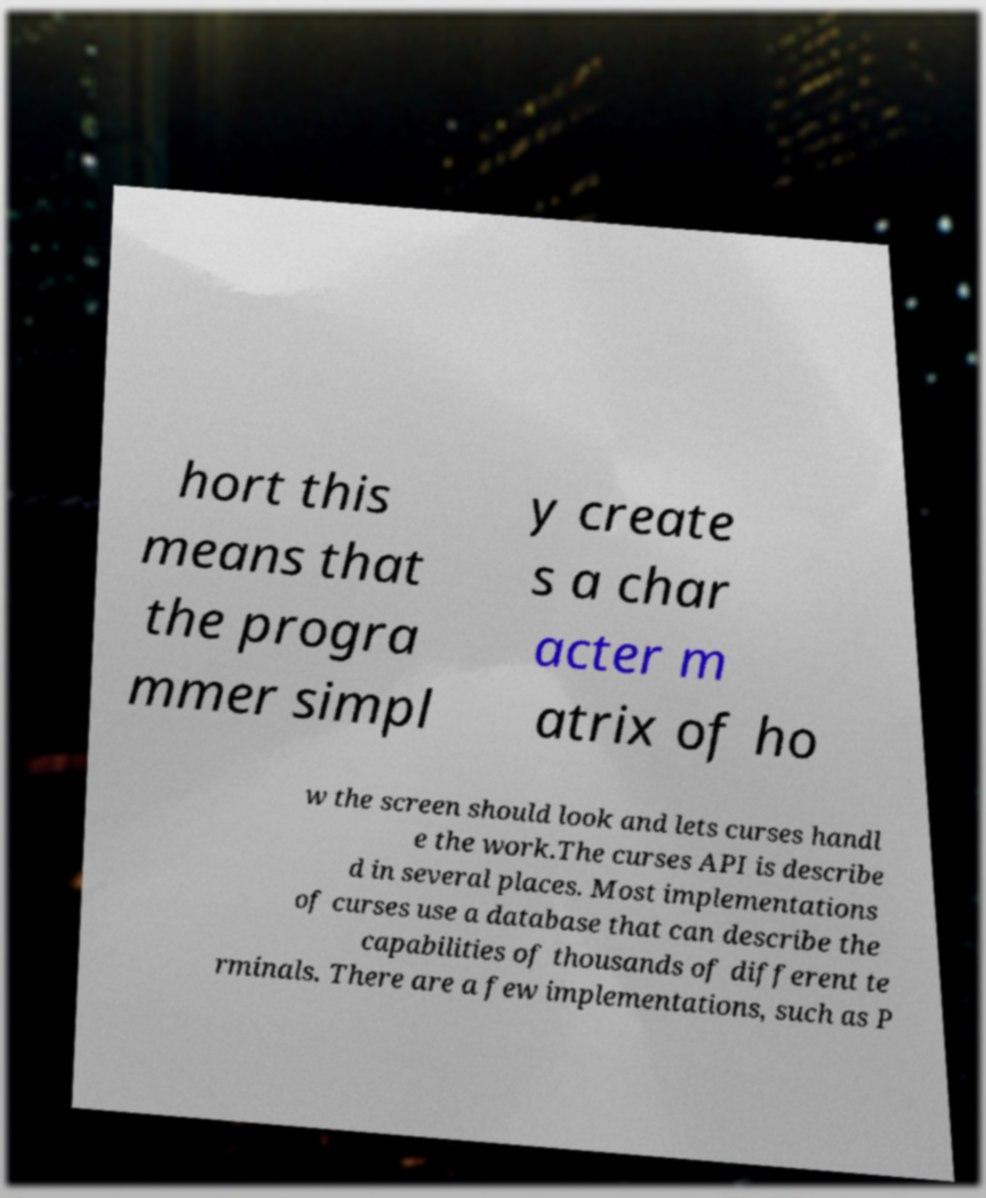For documentation purposes, I need the text within this image transcribed. Could you provide that? hort this means that the progra mmer simpl y create s a char acter m atrix of ho w the screen should look and lets curses handl e the work.The curses API is describe d in several places. Most implementations of curses use a database that can describe the capabilities of thousands of different te rminals. There are a few implementations, such as P 